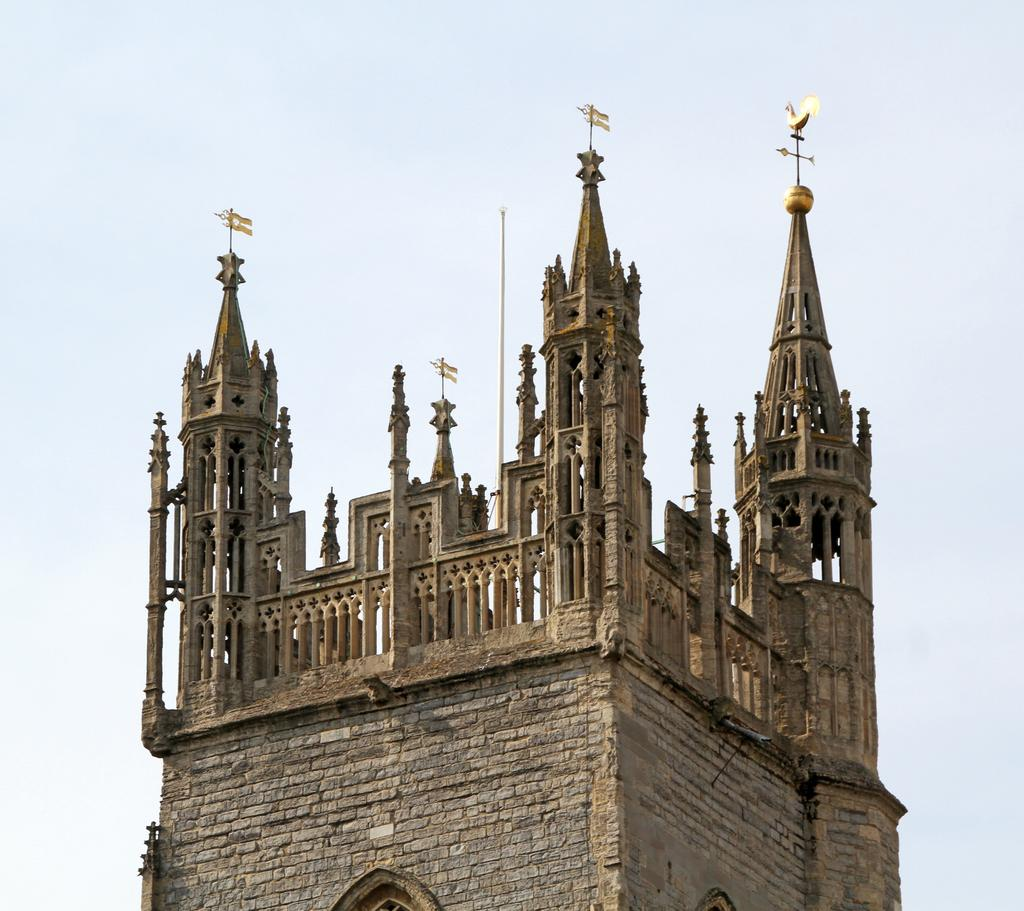What type of structure is present in the image? There is a building in the image. What is the color of the building? The building is brown in color. What can be seen in the background of the image? The sky is visible in the background of the image. What is the color of the sky in the image? The sky is white in color. How many pieces of quartz can be seen in the image? There is no quartz present in the image. Is there a cave visible in the image? There is no cave present in the image. 